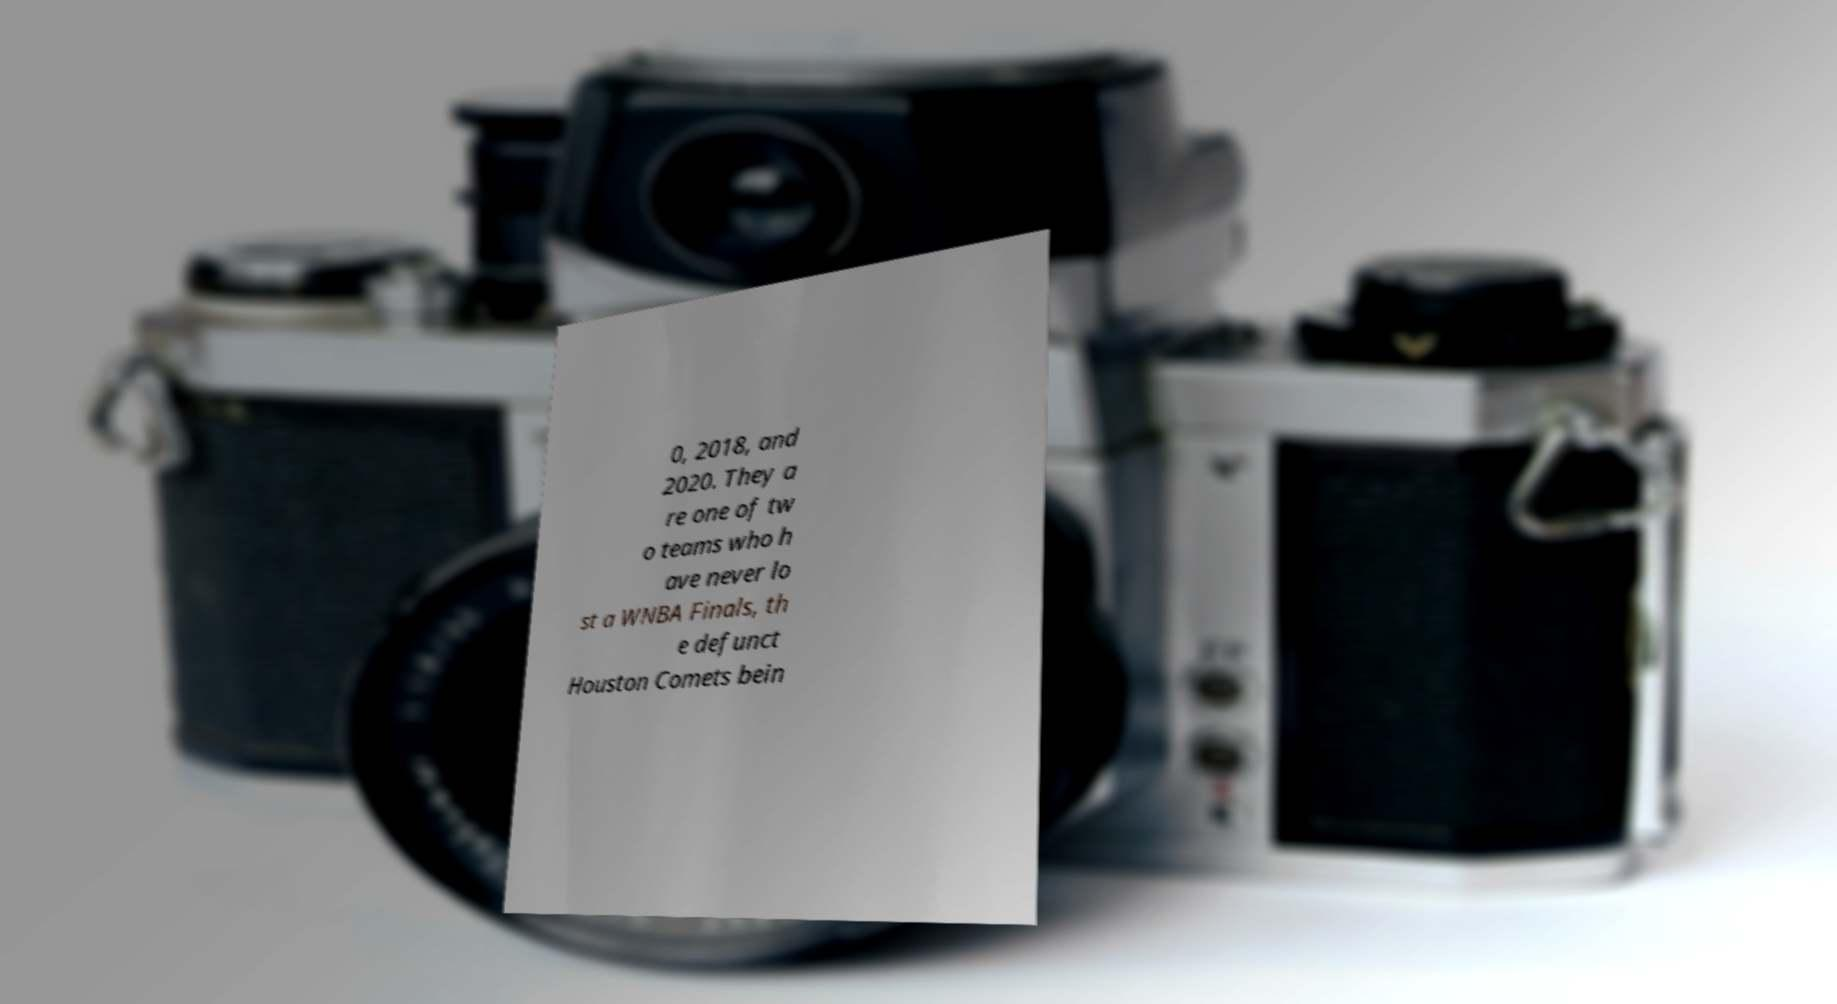Can you accurately transcribe the text from the provided image for me? 0, 2018, and 2020. They a re one of tw o teams who h ave never lo st a WNBA Finals, th e defunct Houston Comets bein 